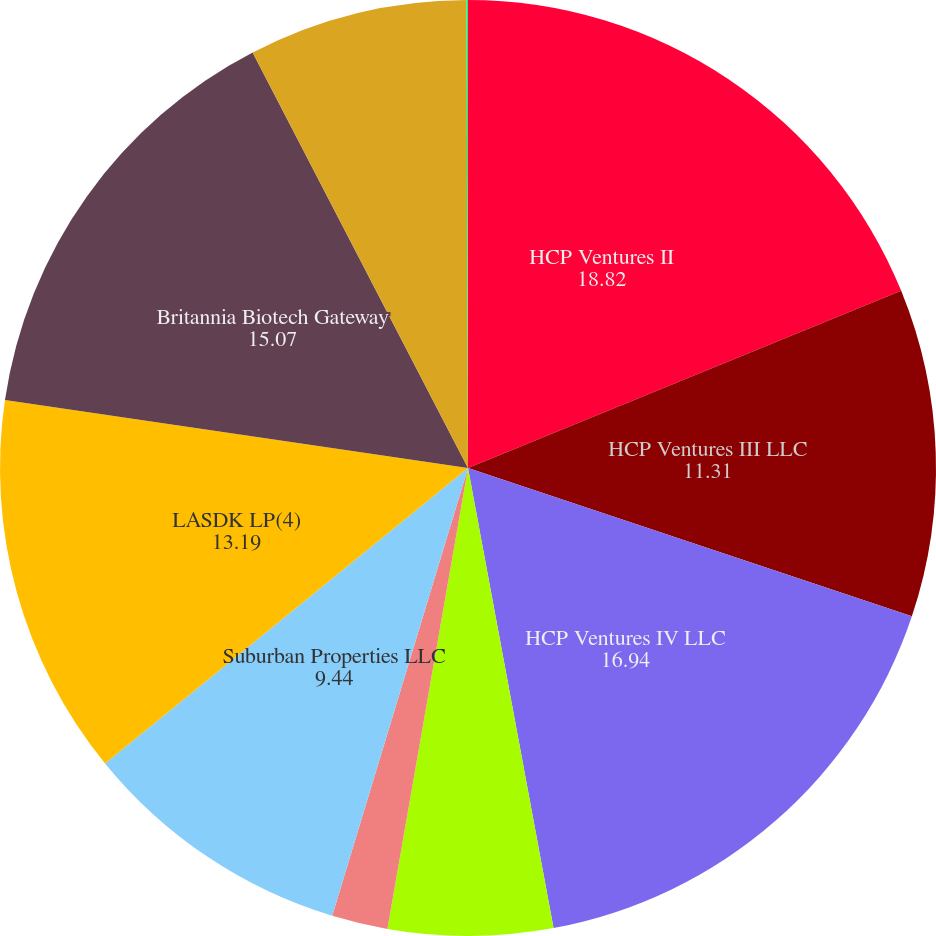<chart> <loc_0><loc_0><loc_500><loc_500><pie_chart><fcel>HCP Ventures II<fcel>HCP Ventures III LLC<fcel>HCP Ventures IV LLC<fcel>Arborwood Living Center LLC(3)<fcel>Greenleaf Living Centers<fcel>Suburban Properties LLC<fcel>LASDK LP(4)<fcel>Britannia Biotech Gateway<fcel>Torrey Pines Science Center<fcel>Edgewood Assisted Living<nl><fcel>18.82%<fcel>11.31%<fcel>16.94%<fcel>5.68%<fcel>1.93%<fcel>9.44%<fcel>13.19%<fcel>15.07%<fcel>7.56%<fcel>0.05%<nl></chart> 